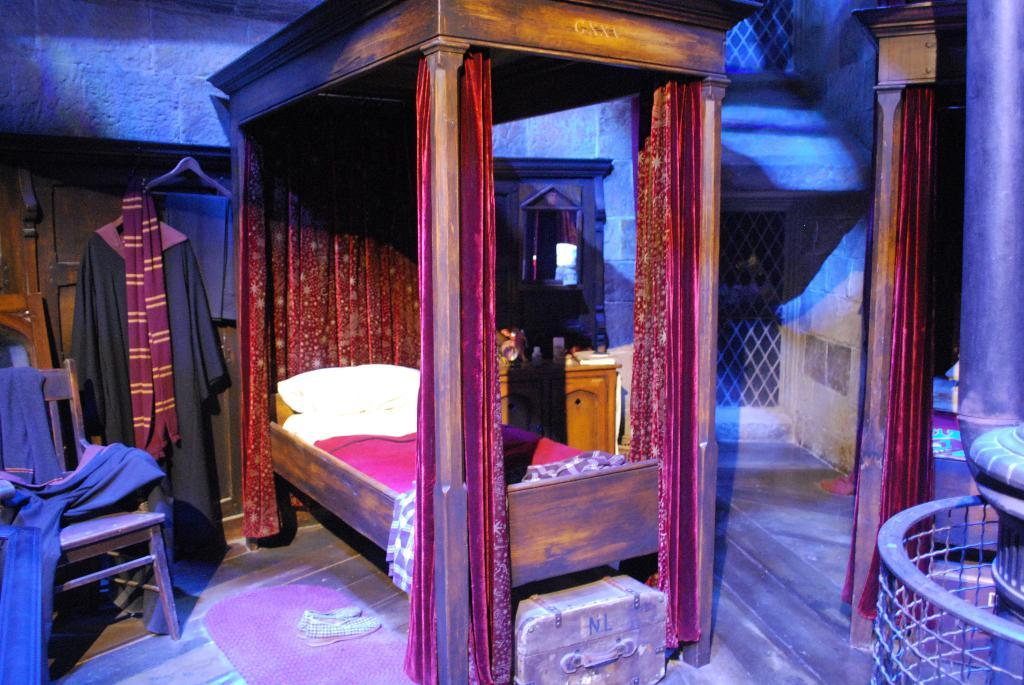What piece of furniture is present in the image? There is a bed in the image. What is stored under the bed? There is a suitcase under the bed. What type of footwear is on the floor? There are shoes on the floor. What is placed on the floor near the door? There is a door mat on the floor. What type of seating is in the image? There is a chair in the image. What type of clothing is in the image? There is a jacket and a scarf in the image. What type of brush is used to clean the shoes in the image? There is no brush visible in the image; only shoes are present on the floor. What type of neck is visible in the image? There is no neck visible in the image; the focus is on furniture and objects. 